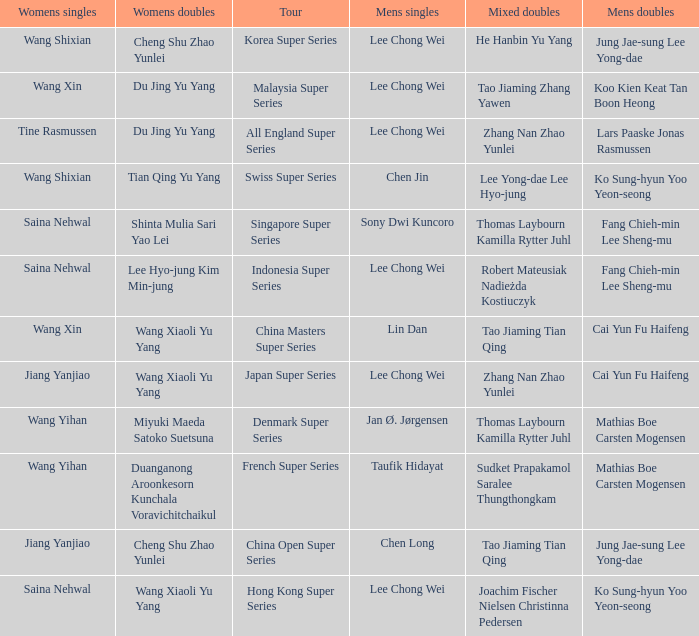Who is the mixed doubled on the tour korea super series? He Hanbin Yu Yang. 